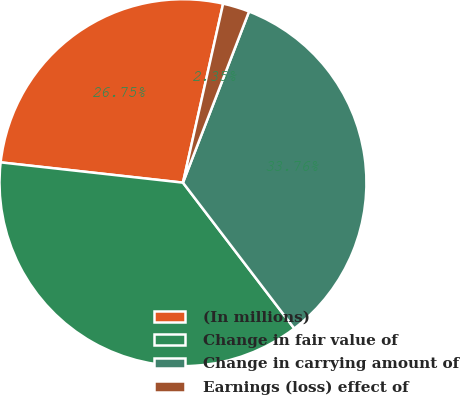<chart> <loc_0><loc_0><loc_500><loc_500><pie_chart><fcel>(In millions)<fcel>Change in fair value of<fcel>Change in carrying amount of<fcel>Earnings (loss) effect of<nl><fcel>26.75%<fcel>37.14%<fcel>33.76%<fcel>2.35%<nl></chart> 